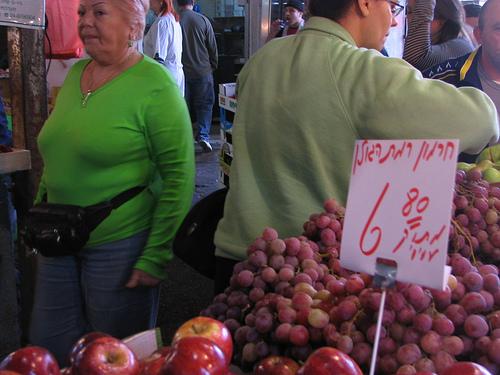Are these apples good for your teeth?
Be succinct. Yes. What color of top is the woman wearing?
Keep it brief. Green. Are any fruits visible?
Be succinct. Yes. IS the women wearing a fanny pack?
Concise answer only. Yes. 